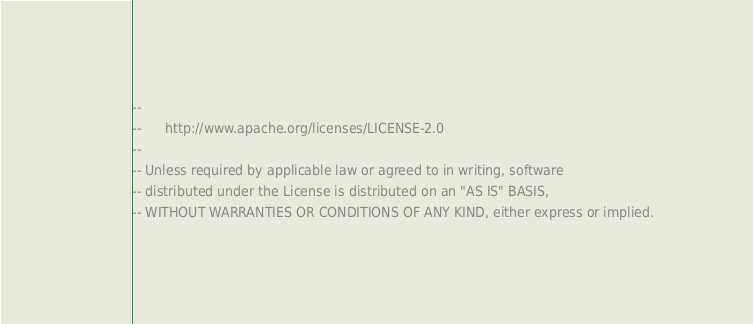Convert code to text. <code><loc_0><loc_0><loc_500><loc_500><_SQL_>-- 
--      http://www.apache.org/licenses/LICENSE-2.0
-- 
-- Unless required by applicable law or agreed to in writing, software
-- distributed under the License is distributed on an "AS IS" BASIS,
-- WITHOUT WARRANTIES OR CONDITIONS OF ANY KIND, either express or implied.</code> 